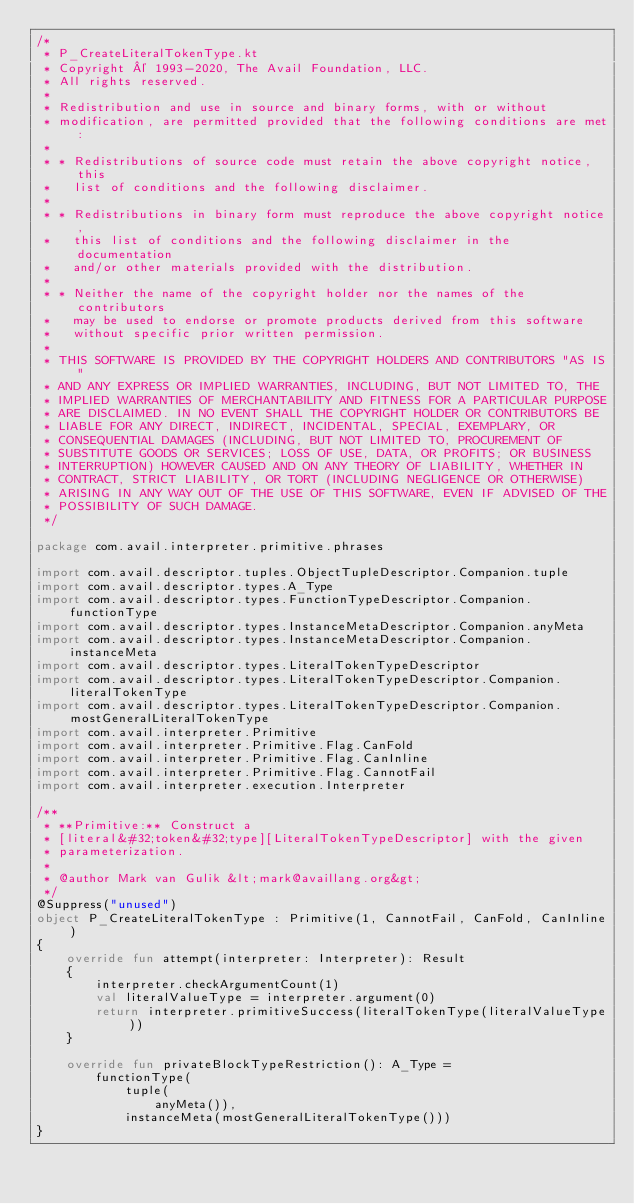<code> <loc_0><loc_0><loc_500><loc_500><_Kotlin_>/*
 * P_CreateLiteralTokenType.kt
 * Copyright © 1993-2020, The Avail Foundation, LLC.
 * All rights reserved.
 *
 * Redistribution and use in source and binary forms, with or without
 * modification, are permitted provided that the following conditions are met:
 *
 * * Redistributions of source code must retain the above copyright notice, this
 *   list of conditions and the following disclaimer.
 *
 * * Redistributions in binary form must reproduce the above copyright notice,
 *   this list of conditions and the following disclaimer in the documentation
 *   and/or other materials provided with the distribution.
 *
 * * Neither the name of the copyright holder nor the names of the contributors
 *   may be used to endorse or promote products derived from this software
 *   without specific prior written permission.
 *
 * THIS SOFTWARE IS PROVIDED BY THE COPYRIGHT HOLDERS AND CONTRIBUTORS "AS IS"
 * AND ANY EXPRESS OR IMPLIED WARRANTIES, INCLUDING, BUT NOT LIMITED TO, THE
 * IMPLIED WARRANTIES OF MERCHANTABILITY AND FITNESS FOR A PARTICULAR PURPOSE
 * ARE DISCLAIMED. IN NO EVENT SHALL THE COPYRIGHT HOLDER OR CONTRIBUTORS BE
 * LIABLE FOR ANY DIRECT, INDIRECT, INCIDENTAL, SPECIAL, EXEMPLARY, OR
 * CONSEQUENTIAL DAMAGES (INCLUDING, BUT NOT LIMITED TO, PROCUREMENT OF
 * SUBSTITUTE GOODS OR SERVICES; LOSS OF USE, DATA, OR PROFITS; OR BUSINESS
 * INTERRUPTION) HOWEVER CAUSED AND ON ANY THEORY OF LIABILITY, WHETHER IN
 * CONTRACT, STRICT LIABILITY, OR TORT (INCLUDING NEGLIGENCE OR OTHERWISE)
 * ARISING IN ANY WAY OUT OF THE USE OF THIS SOFTWARE, EVEN IF ADVISED OF THE
 * POSSIBILITY OF SUCH DAMAGE.
 */

package com.avail.interpreter.primitive.phrases

import com.avail.descriptor.tuples.ObjectTupleDescriptor.Companion.tuple
import com.avail.descriptor.types.A_Type
import com.avail.descriptor.types.FunctionTypeDescriptor.Companion.functionType
import com.avail.descriptor.types.InstanceMetaDescriptor.Companion.anyMeta
import com.avail.descriptor.types.InstanceMetaDescriptor.Companion.instanceMeta
import com.avail.descriptor.types.LiteralTokenTypeDescriptor
import com.avail.descriptor.types.LiteralTokenTypeDescriptor.Companion.literalTokenType
import com.avail.descriptor.types.LiteralTokenTypeDescriptor.Companion.mostGeneralLiteralTokenType
import com.avail.interpreter.Primitive
import com.avail.interpreter.Primitive.Flag.CanFold
import com.avail.interpreter.Primitive.Flag.CanInline
import com.avail.interpreter.Primitive.Flag.CannotFail
import com.avail.interpreter.execution.Interpreter

/**
 * **Primitive:** Construct a
 * [literal&#32;token&#32;type][LiteralTokenTypeDescriptor] with the given
 * parameterization.
 *
 * @author Mark van Gulik &lt;mark@availlang.org&gt;
 */
@Suppress("unused")
object P_CreateLiteralTokenType : Primitive(1, CannotFail, CanFold, CanInline)
{
	override fun attempt(interpreter: Interpreter): Result
	{
		interpreter.checkArgumentCount(1)
		val literalValueType = interpreter.argument(0)
		return interpreter.primitiveSuccess(literalTokenType(literalValueType))
	}

	override fun privateBlockTypeRestriction(): A_Type =
		functionType(
			tuple(
				anyMeta()),
			instanceMeta(mostGeneralLiteralTokenType()))
}
</code> 